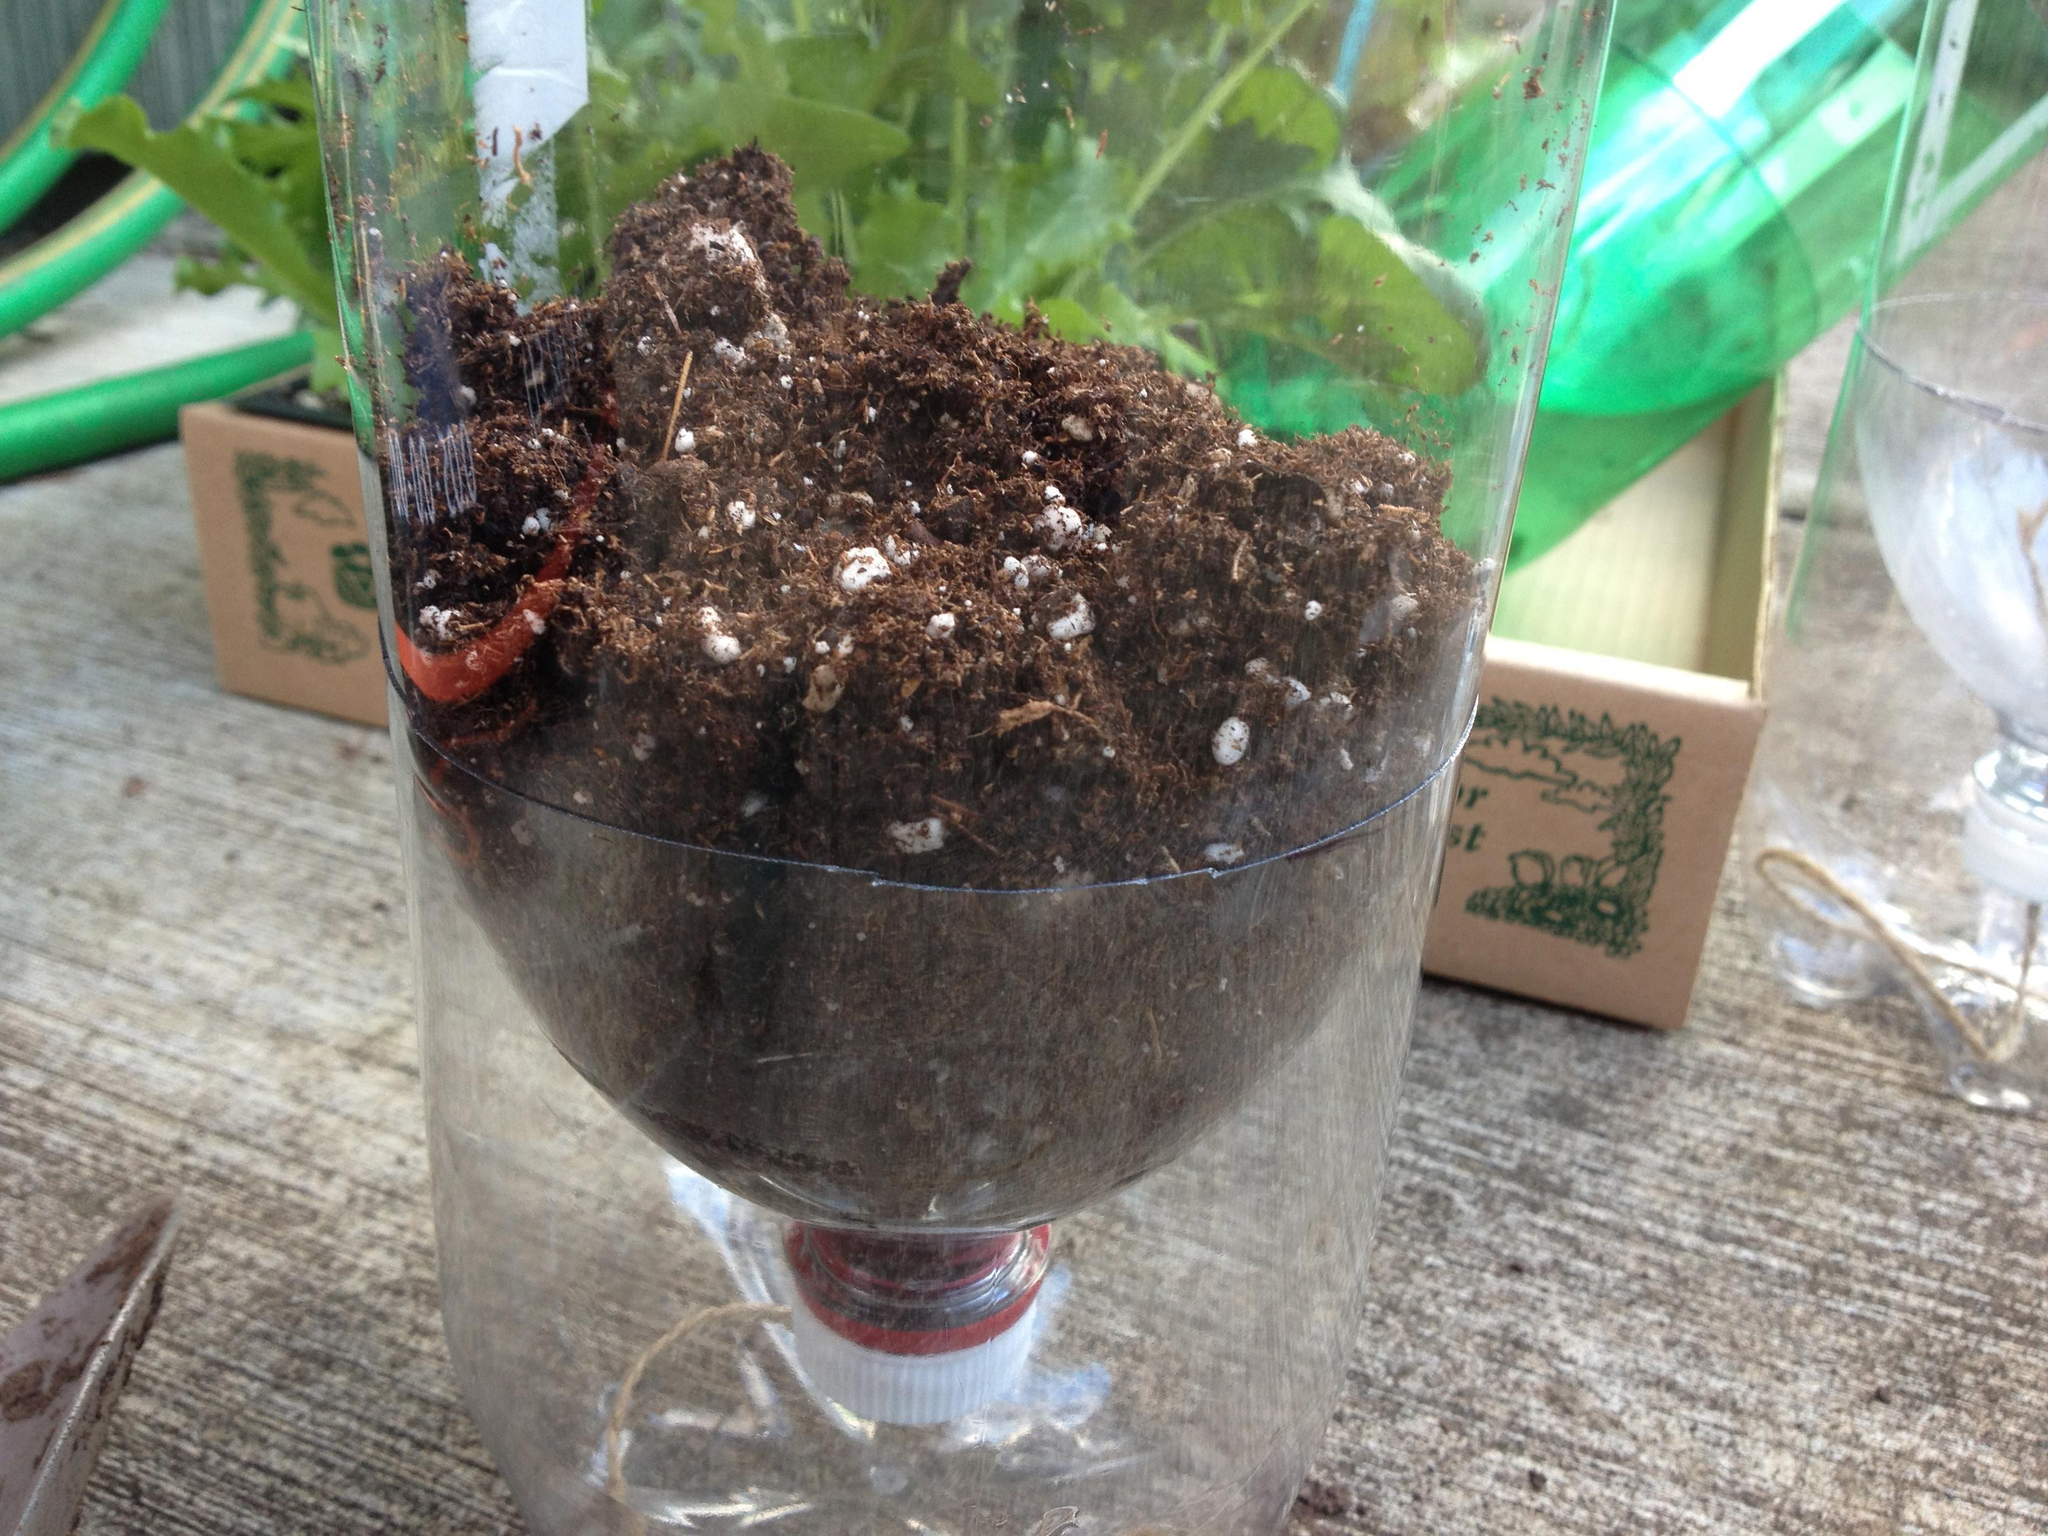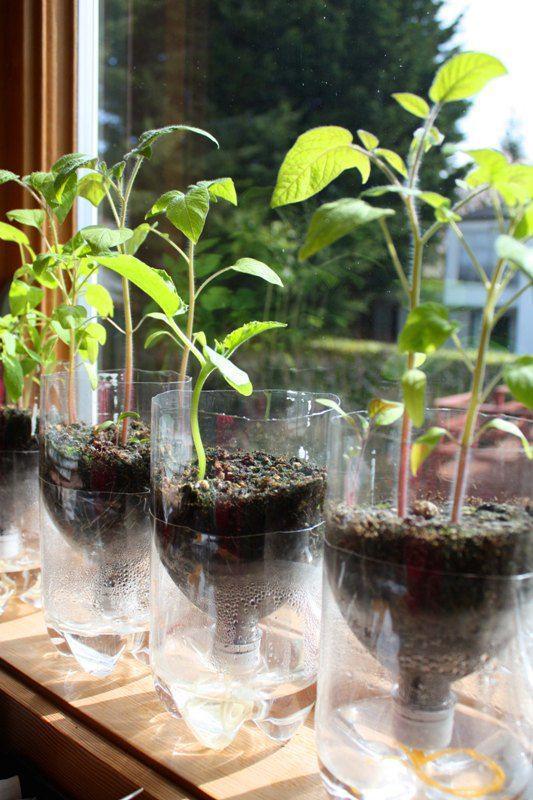The first image is the image on the left, the second image is the image on the right. Evaluate the accuracy of this statement regarding the images: "At least one plastic bottle has been cut in half.". Is it true? Answer yes or no. Yes. The first image is the image on the left, the second image is the image on the right. Evaluate the accuracy of this statement regarding the images: "Human hands are visible holding soda bottles in at least one image.". Is it true? Answer yes or no. No. 